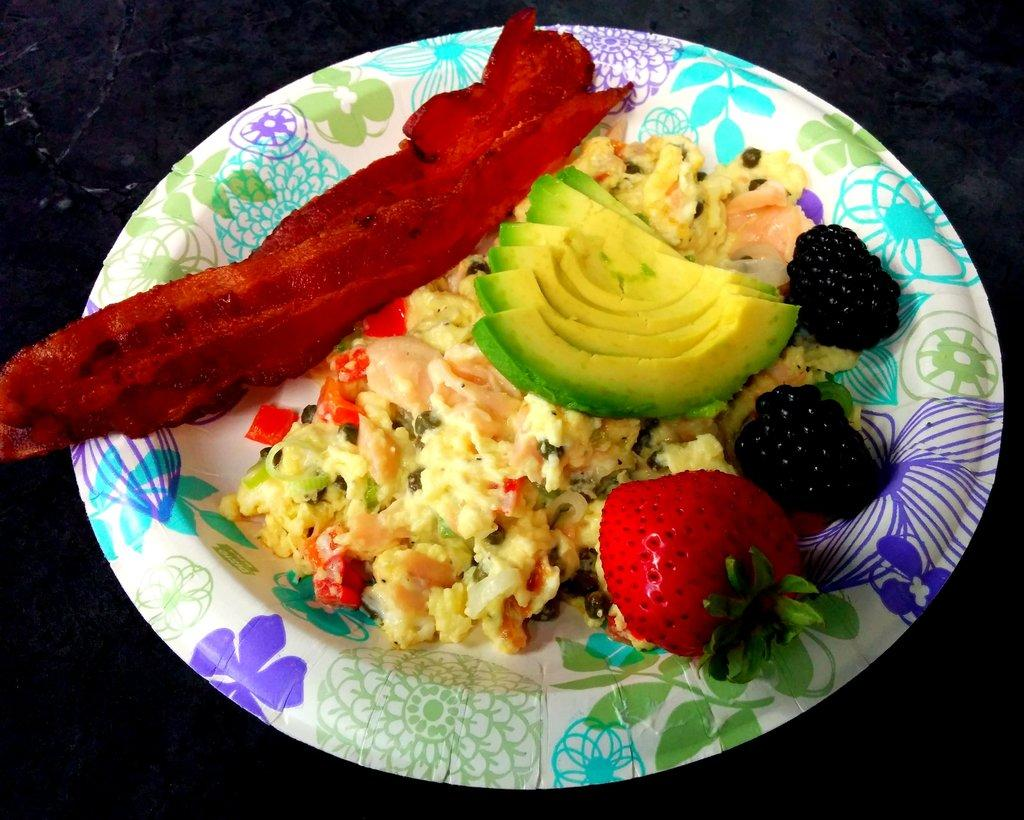What type of plate is visible in the image? There is a disposable plate in the image. What is on the plate? There is food on the plate. What type of wall is visible in the image? There is no wall visible in the image; it only shows a disposable plate with food on it. 